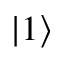<formula> <loc_0><loc_0><loc_500><loc_500>| 1 \rangle</formula> 